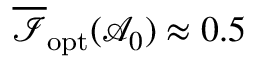<formula> <loc_0><loc_0><loc_500><loc_500>\overline { { \mathcal { I } } } _ { o p t } ( \mathcal { A } _ { 0 } ) \approx 0 . 5 \</formula> 